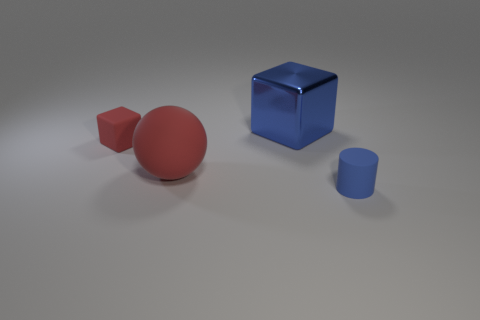Add 1 tiny matte objects. How many objects exist? 5 Subtract all cylinders. How many objects are left? 3 Add 1 matte blocks. How many matte blocks are left? 2 Add 3 large blocks. How many large blocks exist? 4 Subtract 1 red spheres. How many objects are left? 3 Subtract all big cyan matte cubes. Subtract all red matte cubes. How many objects are left? 3 